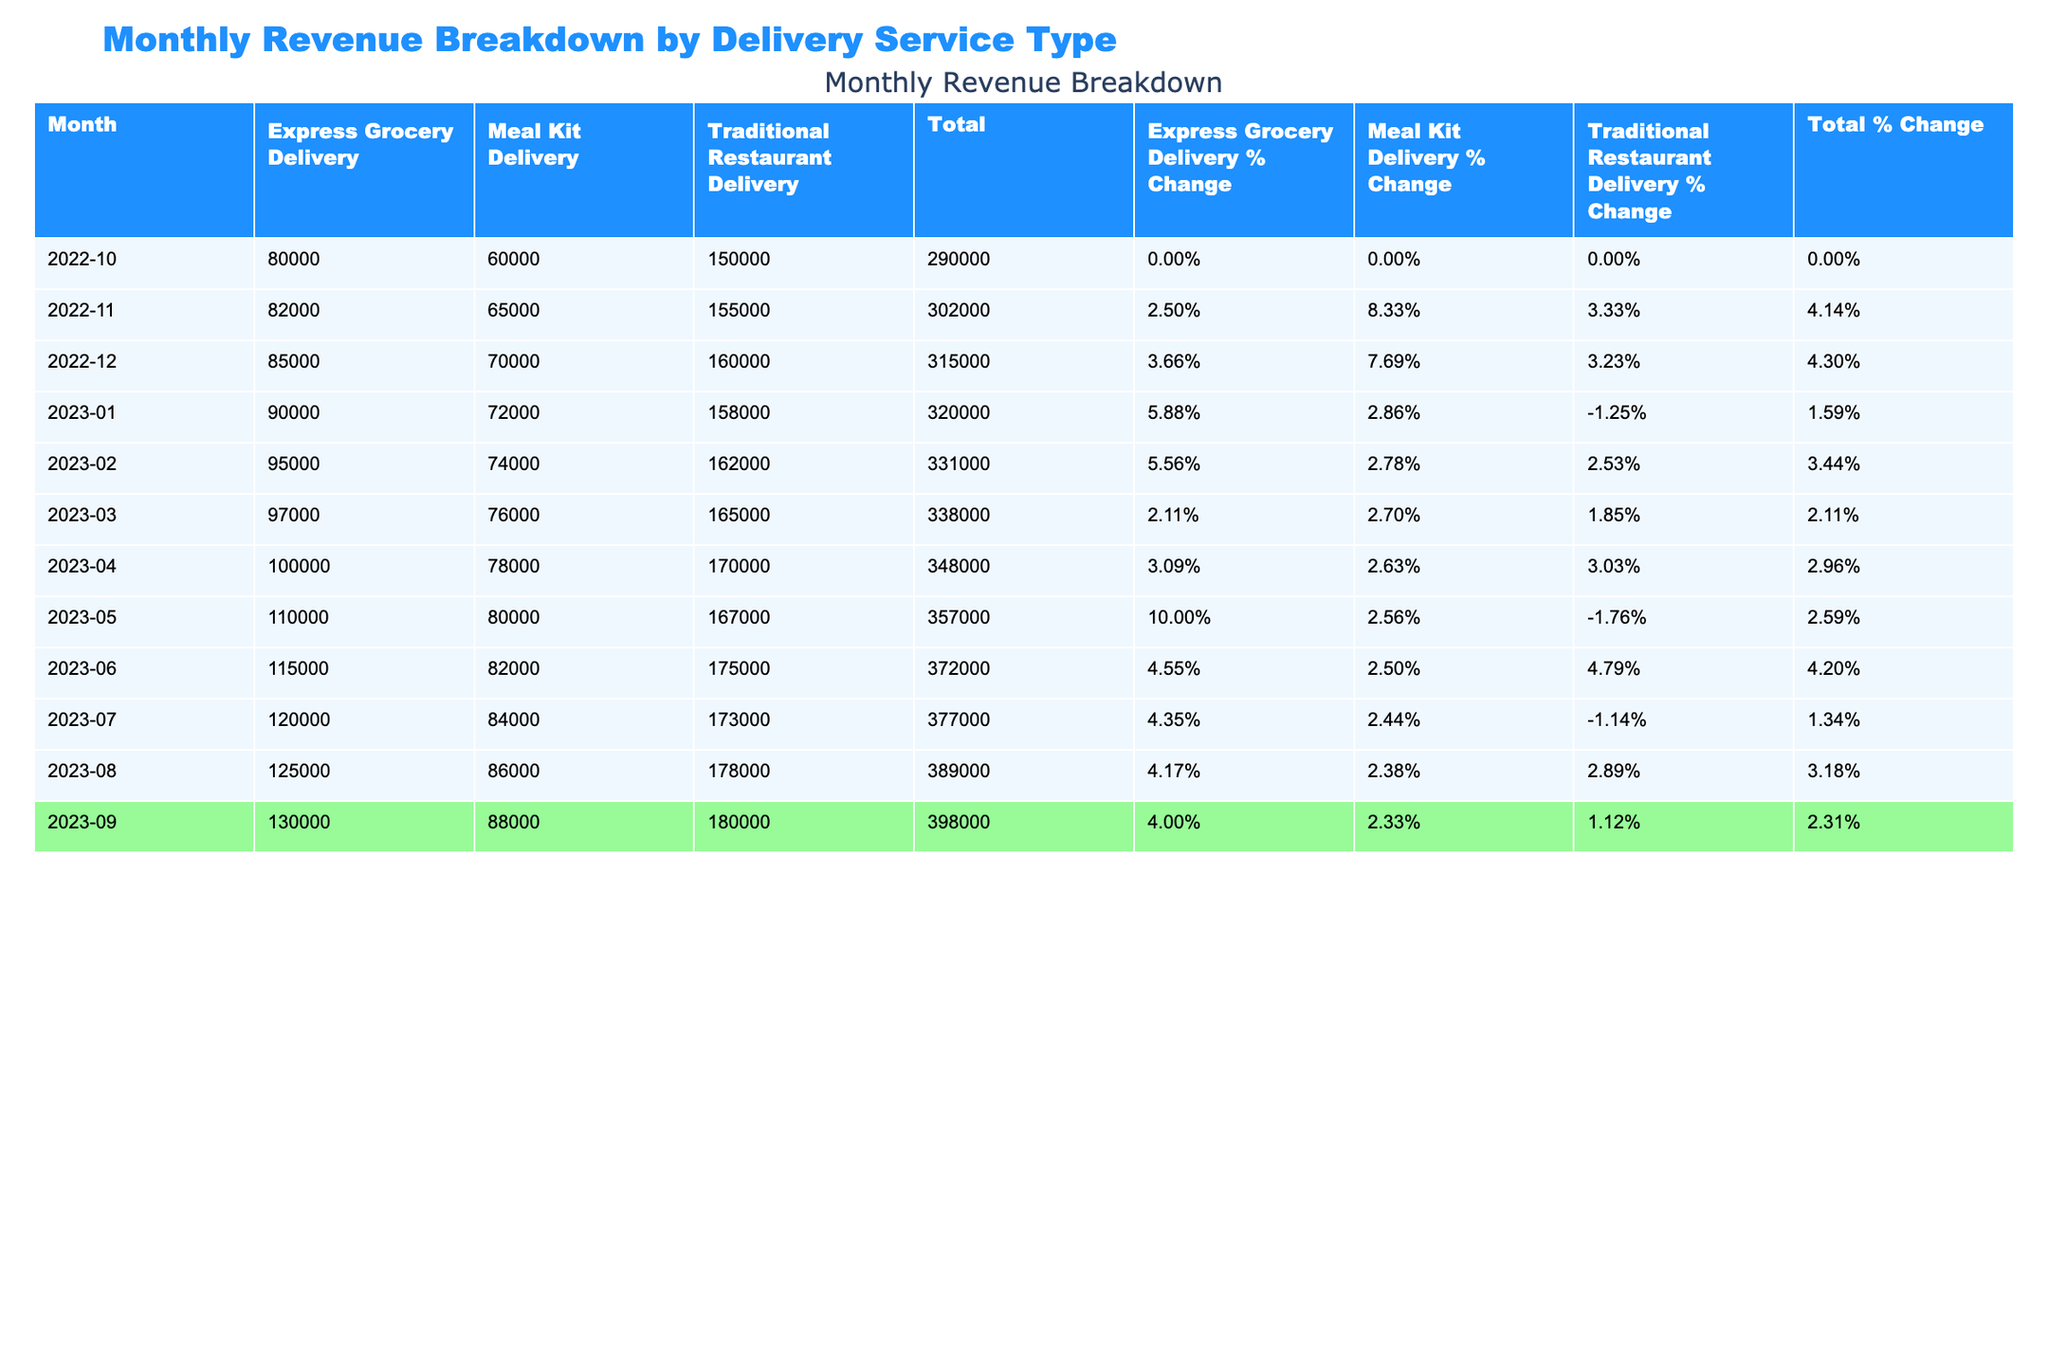What was the highest revenue recorded in any month for Express Grocery Delivery? Looking at the table, the maximum revenue for Express Grocery Delivery occurs in September 2023, with a revenue of 130,000 USD.
Answer: 130,000 USD In which month did Meal Kit Delivery experience the greatest revenue increase compared to the previous month? Observing the table, Meal Kit Delivery saw its largest revenue increase from May 2023 to June 2023, going from 80,000 USD to 82,000 USD, an increase of 2,000 USD.
Answer: June 2023 What was the total revenue for Traditional Restaurant Delivery over the last fiscal year? To find the total for Traditional Restaurant Delivery, sum all the revenues listed under that category: (150,000 + 155,000 + 160,000 + 158,000 + 162,000 + 165,000 + 170,000 + 167,000 + 175,000 + 173,000 + 178,000 + 180,000) = 1,926,000 USD.
Answer: 1,926,000 USD Did the revenue from Express Grocery Delivery ever exceed 120,000 USD in any month? Yes, throughout the table, Express Grocery Delivery exceeded 120,000 USD starting from May 2023 onward, reaching a peak in September 2023 with 130,000 USD.
Answer: Yes What is the average monthly revenue for Meal Kit Delivery over the 12 months? The total revenue for Meal Kit Delivery is 760,000 USD (calculated by summing all monthly revenues) divided by 12 months, which gives an average of approximately 63,333.33 USD.
Answer: 63,333.33 USD In which month did Traditional Restaurant Delivery see the most significant percentage growth from the previous month? Analyzing the percentage changes, the largest growth for Traditional Restaurant Delivery occurred from April 2023 (170,000 USD) to May 2023 (167,000 USD) with an increase calculated at about 2.94%.
Answer: April 2023 What was the lowest revenue recorded for any delivery service type in the 12-month period? The lowest revenue is for Meal Kit Delivery in the month of October 2022, which recorded 60,000 USD.
Answer: 60,000 USD How much did the total revenue for Milk Kit Delivery fluctuate month over month when comparing the first and last month of the fiscal year? Comparing October 2022 (60,000 USD) to September 2023 (88,000 USD), the total fluctuation is 28,000 USD from the start to the end of the fiscal year.
Answer: 28,000 USD Was there a month where all delivery service types recorded an increase in revenue compared to the previous month? Looking through the data, all service types recorded an increase in revenue from January 2023 to February 2023.
Answer: Yes What is the percentage increase in revenue for Express Grocery Delivery from October 2022 to September 2023? The revenue increased from 80,000 USD in October 2022 to 130,000 USD in September 2023, which is a percentage increase of ((130,000 - 80,000) / 80,000) * 100 = 62.5%.
Answer: 62.5% 